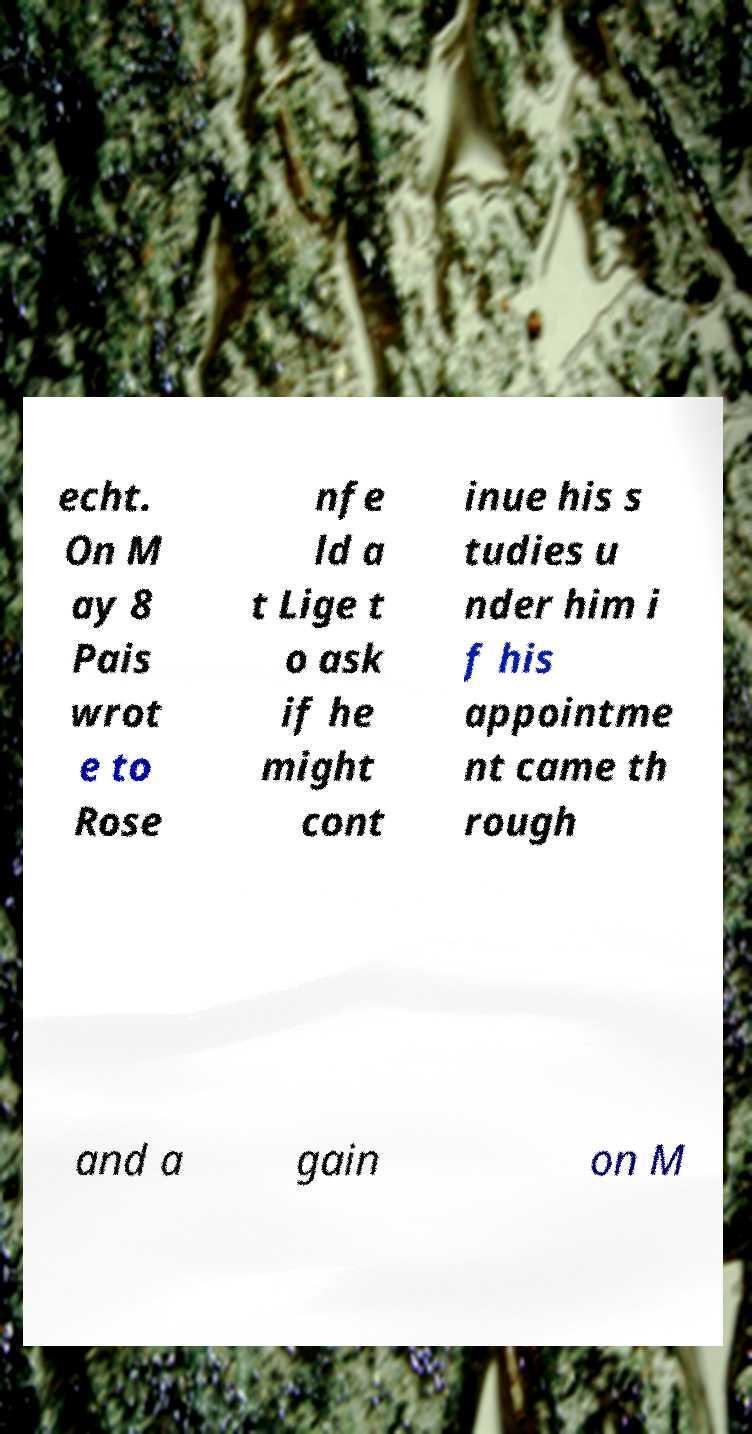Could you assist in decoding the text presented in this image and type it out clearly? echt. On M ay 8 Pais wrot e to Rose nfe ld a t Lige t o ask if he might cont inue his s tudies u nder him i f his appointme nt came th rough and a gain on M 